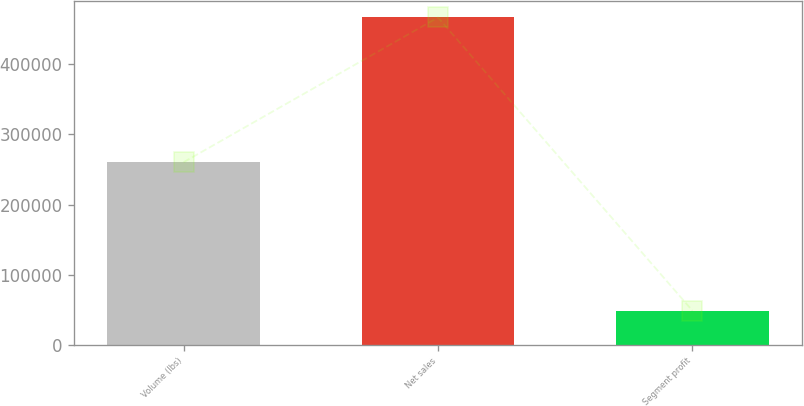<chart> <loc_0><loc_0><loc_500><loc_500><bar_chart><fcel>Volume (lbs)<fcel>Net sales<fcel>Segment profit<nl><fcel>260450<fcel>466811<fcel>48829<nl></chart> 